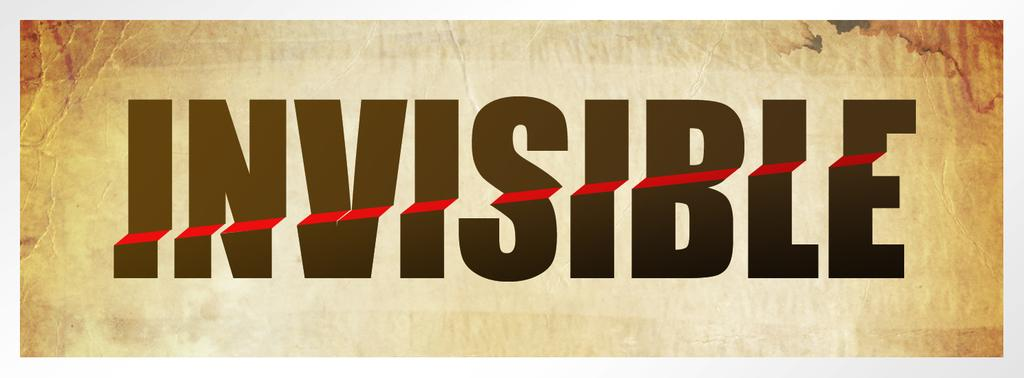Provide a one-sentence caption for the provided image. The word Invisible in black with a red line through it. 